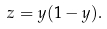<formula> <loc_0><loc_0><loc_500><loc_500>z = y ( 1 - y ) .</formula> 